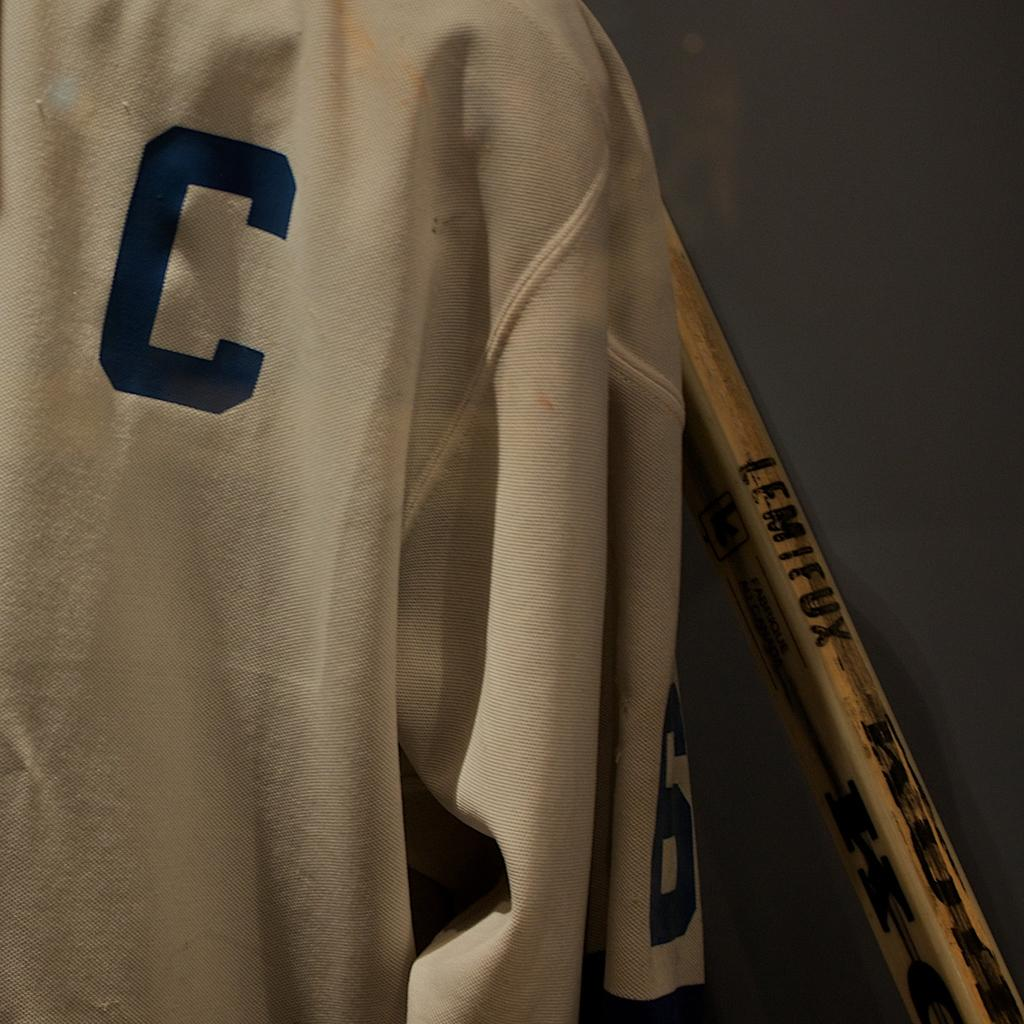<image>
Describe the image concisely. A WHITE JERSEY WITH INITALS C HANGING BY A LEMIFUX WOODEN BAT 